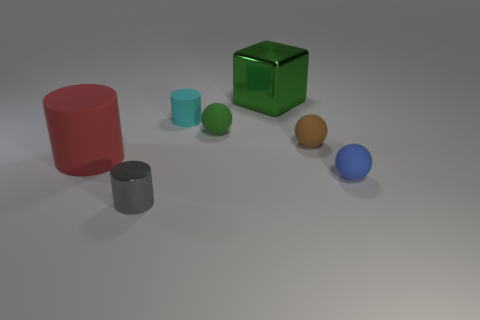Subtract all matte cylinders. How many cylinders are left? 1 Add 2 purple metal cylinders. How many objects exist? 9 Subtract all purple balls. Subtract all cyan cylinders. How many balls are left? 3 Subtract all small blue spheres. Subtract all cyan cylinders. How many objects are left? 5 Add 6 small gray cylinders. How many small gray cylinders are left? 7 Add 6 green matte things. How many green matte things exist? 7 Subtract 0 blue cubes. How many objects are left? 7 Subtract all cubes. How many objects are left? 6 